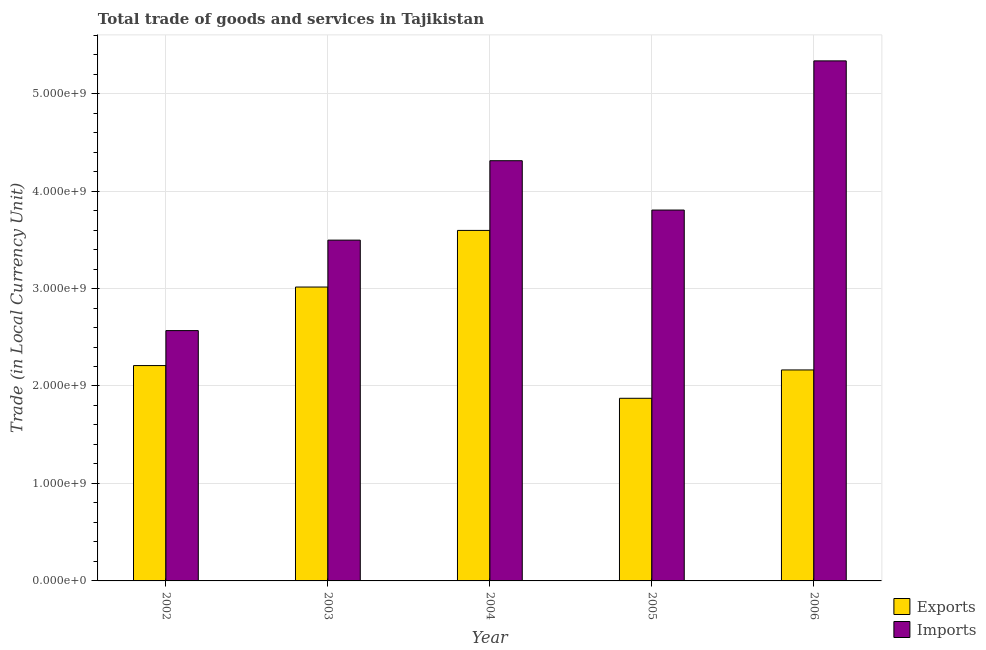How many groups of bars are there?
Keep it short and to the point. 5. Are the number of bars per tick equal to the number of legend labels?
Your answer should be compact. Yes. What is the label of the 3rd group of bars from the left?
Offer a terse response. 2004. What is the imports of goods and services in 2002?
Make the answer very short. 2.57e+09. Across all years, what is the maximum imports of goods and services?
Ensure brevity in your answer.  5.34e+09. Across all years, what is the minimum export of goods and services?
Offer a terse response. 1.87e+09. What is the total imports of goods and services in the graph?
Your response must be concise. 1.95e+1. What is the difference between the imports of goods and services in 2004 and that in 2005?
Offer a very short reply. 5.06e+08. What is the difference between the export of goods and services in 2006 and the imports of goods and services in 2003?
Your answer should be compact. -8.51e+08. What is the average export of goods and services per year?
Offer a terse response. 2.57e+09. What is the ratio of the imports of goods and services in 2002 to that in 2006?
Provide a succinct answer. 0.48. What is the difference between the highest and the second highest export of goods and services?
Keep it short and to the point. 5.81e+08. What is the difference between the highest and the lowest imports of goods and services?
Offer a very short reply. 2.77e+09. In how many years, is the imports of goods and services greater than the average imports of goods and services taken over all years?
Offer a terse response. 2. Is the sum of the imports of goods and services in 2002 and 2004 greater than the maximum export of goods and services across all years?
Your response must be concise. Yes. What does the 2nd bar from the left in 2004 represents?
Offer a very short reply. Imports. What does the 1st bar from the right in 2003 represents?
Provide a succinct answer. Imports. Are all the bars in the graph horizontal?
Provide a short and direct response. No. What is the difference between two consecutive major ticks on the Y-axis?
Your response must be concise. 1.00e+09. Are the values on the major ticks of Y-axis written in scientific E-notation?
Offer a very short reply. Yes. Does the graph contain any zero values?
Keep it short and to the point. No. How many legend labels are there?
Your answer should be very brief. 2. How are the legend labels stacked?
Ensure brevity in your answer.  Vertical. What is the title of the graph?
Keep it short and to the point. Total trade of goods and services in Tajikistan. What is the label or title of the Y-axis?
Your answer should be compact. Trade (in Local Currency Unit). What is the Trade (in Local Currency Unit) of Exports in 2002?
Your answer should be compact. 2.21e+09. What is the Trade (in Local Currency Unit) in Imports in 2002?
Your answer should be compact. 2.57e+09. What is the Trade (in Local Currency Unit) of Exports in 2003?
Your answer should be very brief. 3.02e+09. What is the Trade (in Local Currency Unit) of Imports in 2003?
Provide a short and direct response. 3.50e+09. What is the Trade (in Local Currency Unit) in Exports in 2004?
Your response must be concise. 3.60e+09. What is the Trade (in Local Currency Unit) in Imports in 2004?
Provide a short and direct response. 4.31e+09. What is the Trade (in Local Currency Unit) of Exports in 2005?
Give a very brief answer. 1.87e+09. What is the Trade (in Local Currency Unit) of Imports in 2005?
Your answer should be very brief. 3.81e+09. What is the Trade (in Local Currency Unit) of Exports in 2006?
Offer a very short reply. 2.16e+09. What is the Trade (in Local Currency Unit) in Imports in 2006?
Ensure brevity in your answer.  5.34e+09. Across all years, what is the maximum Trade (in Local Currency Unit) in Exports?
Your answer should be compact. 3.60e+09. Across all years, what is the maximum Trade (in Local Currency Unit) of Imports?
Provide a succinct answer. 5.34e+09. Across all years, what is the minimum Trade (in Local Currency Unit) of Exports?
Your response must be concise. 1.87e+09. Across all years, what is the minimum Trade (in Local Currency Unit) of Imports?
Make the answer very short. 2.57e+09. What is the total Trade (in Local Currency Unit) in Exports in the graph?
Your answer should be compact. 1.29e+1. What is the total Trade (in Local Currency Unit) in Imports in the graph?
Keep it short and to the point. 1.95e+1. What is the difference between the Trade (in Local Currency Unit) in Exports in 2002 and that in 2003?
Give a very brief answer. -8.06e+08. What is the difference between the Trade (in Local Currency Unit) in Imports in 2002 and that in 2003?
Provide a succinct answer. -9.28e+08. What is the difference between the Trade (in Local Currency Unit) in Exports in 2002 and that in 2004?
Provide a succinct answer. -1.39e+09. What is the difference between the Trade (in Local Currency Unit) of Imports in 2002 and that in 2004?
Your answer should be very brief. -1.74e+09. What is the difference between the Trade (in Local Currency Unit) of Exports in 2002 and that in 2005?
Offer a terse response. 3.36e+08. What is the difference between the Trade (in Local Currency Unit) in Imports in 2002 and that in 2005?
Provide a short and direct response. -1.24e+09. What is the difference between the Trade (in Local Currency Unit) of Exports in 2002 and that in 2006?
Provide a succinct answer. 4.48e+07. What is the difference between the Trade (in Local Currency Unit) in Imports in 2002 and that in 2006?
Offer a terse response. -2.77e+09. What is the difference between the Trade (in Local Currency Unit) of Exports in 2003 and that in 2004?
Your response must be concise. -5.81e+08. What is the difference between the Trade (in Local Currency Unit) in Imports in 2003 and that in 2004?
Make the answer very short. -8.15e+08. What is the difference between the Trade (in Local Currency Unit) of Exports in 2003 and that in 2005?
Your answer should be very brief. 1.14e+09. What is the difference between the Trade (in Local Currency Unit) of Imports in 2003 and that in 2005?
Ensure brevity in your answer.  -3.09e+08. What is the difference between the Trade (in Local Currency Unit) of Exports in 2003 and that in 2006?
Your answer should be very brief. 8.51e+08. What is the difference between the Trade (in Local Currency Unit) in Imports in 2003 and that in 2006?
Make the answer very short. -1.84e+09. What is the difference between the Trade (in Local Currency Unit) in Exports in 2004 and that in 2005?
Offer a very short reply. 1.72e+09. What is the difference between the Trade (in Local Currency Unit) in Imports in 2004 and that in 2005?
Offer a terse response. 5.06e+08. What is the difference between the Trade (in Local Currency Unit) of Exports in 2004 and that in 2006?
Give a very brief answer. 1.43e+09. What is the difference between the Trade (in Local Currency Unit) of Imports in 2004 and that in 2006?
Your answer should be compact. -1.02e+09. What is the difference between the Trade (in Local Currency Unit) of Exports in 2005 and that in 2006?
Provide a succinct answer. -2.91e+08. What is the difference between the Trade (in Local Currency Unit) of Imports in 2005 and that in 2006?
Your answer should be very brief. -1.53e+09. What is the difference between the Trade (in Local Currency Unit) in Exports in 2002 and the Trade (in Local Currency Unit) in Imports in 2003?
Ensure brevity in your answer.  -1.29e+09. What is the difference between the Trade (in Local Currency Unit) of Exports in 2002 and the Trade (in Local Currency Unit) of Imports in 2004?
Make the answer very short. -2.10e+09. What is the difference between the Trade (in Local Currency Unit) in Exports in 2002 and the Trade (in Local Currency Unit) in Imports in 2005?
Your answer should be very brief. -1.60e+09. What is the difference between the Trade (in Local Currency Unit) in Exports in 2002 and the Trade (in Local Currency Unit) in Imports in 2006?
Give a very brief answer. -3.13e+09. What is the difference between the Trade (in Local Currency Unit) of Exports in 2003 and the Trade (in Local Currency Unit) of Imports in 2004?
Keep it short and to the point. -1.30e+09. What is the difference between the Trade (in Local Currency Unit) in Exports in 2003 and the Trade (in Local Currency Unit) in Imports in 2005?
Your answer should be very brief. -7.90e+08. What is the difference between the Trade (in Local Currency Unit) of Exports in 2003 and the Trade (in Local Currency Unit) of Imports in 2006?
Offer a very short reply. -2.32e+09. What is the difference between the Trade (in Local Currency Unit) in Exports in 2004 and the Trade (in Local Currency Unit) in Imports in 2005?
Provide a short and direct response. -2.09e+08. What is the difference between the Trade (in Local Currency Unit) of Exports in 2004 and the Trade (in Local Currency Unit) of Imports in 2006?
Ensure brevity in your answer.  -1.74e+09. What is the difference between the Trade (in Local Currency Unit) of Exports in 2005 and the Trade (in Local Currency Unit) of Imports in 2006?
Offer a very short reply. -3.46e+09. What is the average Trade (in Local Currency Unit) of Exports per year?
Make the answer very short. 2.57e+09. What is the average Trade (in Local Currency Unit) in Imports per year?
Keep it short and to the point. 3.90e+09. In the year 2002, what is the difference between the Trade (in Local Currency Unit) of Exports and Trade (in Local Currency Unit) of Imports?
Provide a succinct answer. -3.59e+08. In the year 2003, what is the difference between the Trade (in Local Currency Unit) in Exports and Trade (in Local Currency Unit) in Imports?
Make the answer very short. -4.81e+08. In the year 2004, what is the difference between the Trade (in Local Currency Unit) of Exports and Trade (in Local Currency Unit) of Imports?
Keep it short and to the point. -7.15e+08. In the year 2005, what is the difference between the Trade (in Local Currency Unit) of Exports and Trade (in Local Currency Unit) of Imports?
Make the answer very short. -1.93e+09. In the year 2006, what is the difference between the Trade (in Local Currency Unit) of Exports and Trade (in Local Currency Unit) of Imports?
Keep it short and to the point. -3.17e+09. What is the ratio of the Trade (in Local Currency Unit) in Exports in 2002 to that in 2003?
Give a very brief answer. 0.73. What is the ratio of the Trade (in Local Currency Unit) in Imports in 2002 to that in 2003?
Your answer should be compact. 0.73. What is the ratio of the Trade (in Local Currency Unit) in Exports in 2002 to that in 2004?
Your answer should be very brief. 0.61. What is the ratio of the Trade (in Local Currency Unit) in Imports in 2002 to that in 2004?
Provide a short and direct response. 0.6. What is the ratio of the Trade (in Local Currency Unit) of Exports in 2002 to that in 2005?
Offer a very short reply. 1.18. What is the ratio of the Trade (in Local Currency Unit) in Imports in 2002 to that in 2005?
Keep it short and to the point. 0.68. What is the ratio of the Trade (in Local Currency Unit) in Exports in 2002 to that in 2006?
Make the answer very short. 1.02. What is the ratio of the Trade (in Local Currency Unit) of Imports in 2002 to that in 2006?
Offer a very short reply. 0.48. What is the ratio of the Trade (in Local Currency Unit) of Exports in 2003 to that in 2004?
Provide a succinct answer. 0.84. What is the ratio of the Trade (in Local Currency Unit) in Imports in 2003 to that in 2004?
Make the answer very short. 0.81. What is the ratio of the Trade (in Local Currency Unit) in Exports in 2003 to that in 2005?
Offer a very short reply. 1.61. What is the ratio of the Trade (in Local Currency Unit) in Imports in 2003 to that in 2005?
Offer a very short reply. 0.92. What is the ratio of the Trade (in Local Currency Unit) in Exports in 2003 to that in 2006?
Make the answer very short. 1.39. What is the ratio of the Trade (in Local Currency Unit) of Imports in 2003 to that in 2006?
Provide a succinct answer. 0.66. What is the ratio of the Trade (in Local Currency Unit) in Exports in 2004 to that in 2005?
Your response must be concise. 1.92. What is the ratio of the Trade (in Local Currency Unit) of Imports in 2004 to that in 2005?
Your answer should be compact. 1.13. What is the ratio of the Trade (in Local Currency Unit) of Exports in 2004 to that in 2006?
Give a very brief answer. 1.66. What is the ratio of the Trade (in Local Currency Unit) in Imports in 2004 to that in 2006?
Make the answer very short. 0.81. What is the ratio of the Trade (in Local Currency Unit) of Exports in 2005 to that in 2006?
Make the answer very short. 0.87. What is the ratio of the Trade (in Local Currency Unit) in Imports in 2005 to that in 2006?
Provide a short and direct response. 0.71. What is the difference between the highest and the second highest Trade (in Local Currency Unit) of Exports?
Your response must be concise. 5.81e+08. What is the difference between the highest and the second highest Trade (in Local Currency Unit) in Imports?
Give a very brief answer. 1.02e+09. What is the difference between the highest and the lowest Trade (in Local Currency Unit) of Exports?
Keep it short and to the point. 1.72e+09. What is the difference between the highest and the lowest Trade (in Local Currency Unit) in Imports?
Give a very brief answer. 2.77e+09. 